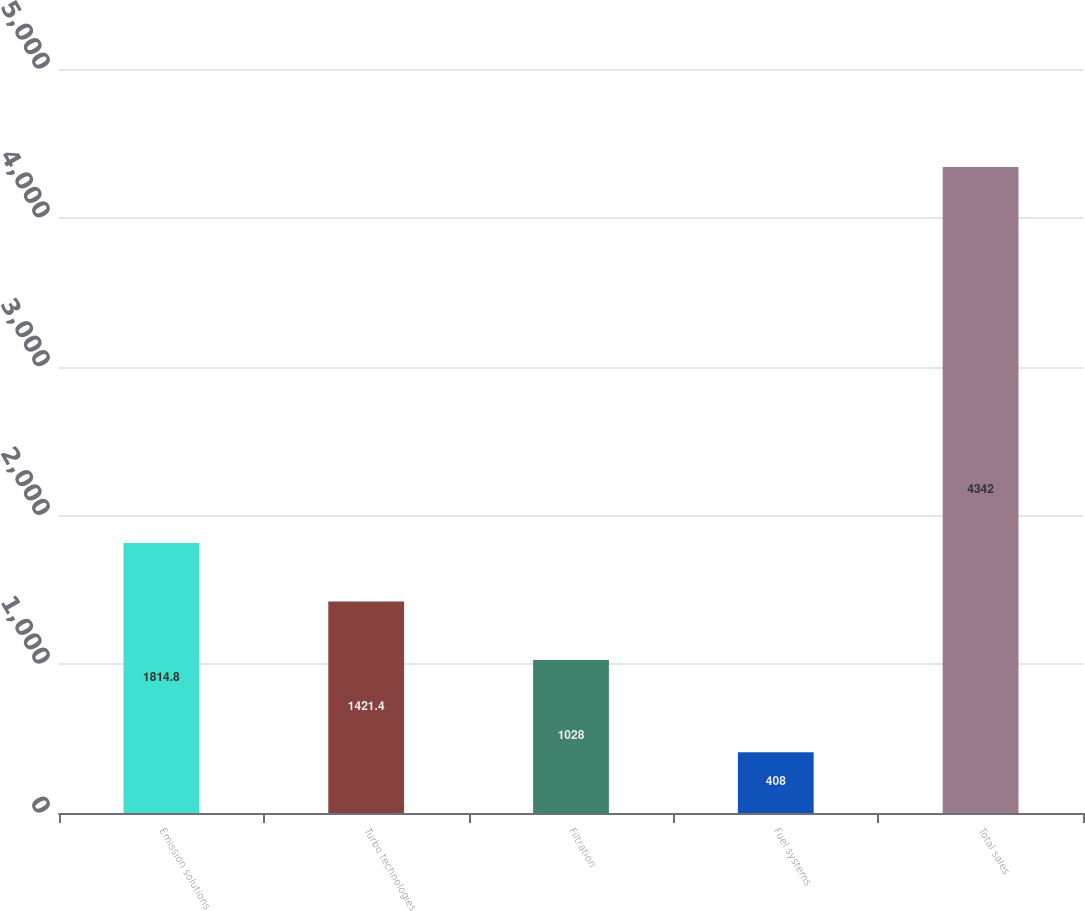Convert chart to OTSL. <chart><loc_0><loc_0><loc_500><loc_500><bar_chart><fcel>Emission solutions<fcel>Turbo technologies<fcel>Filtration<fcel>Fuel systems<fcel>Total sales<nl><fcel>1814.8<fcel>1421.4<fcel>1028<fcel>408<fcel>4342<nl></chart> 